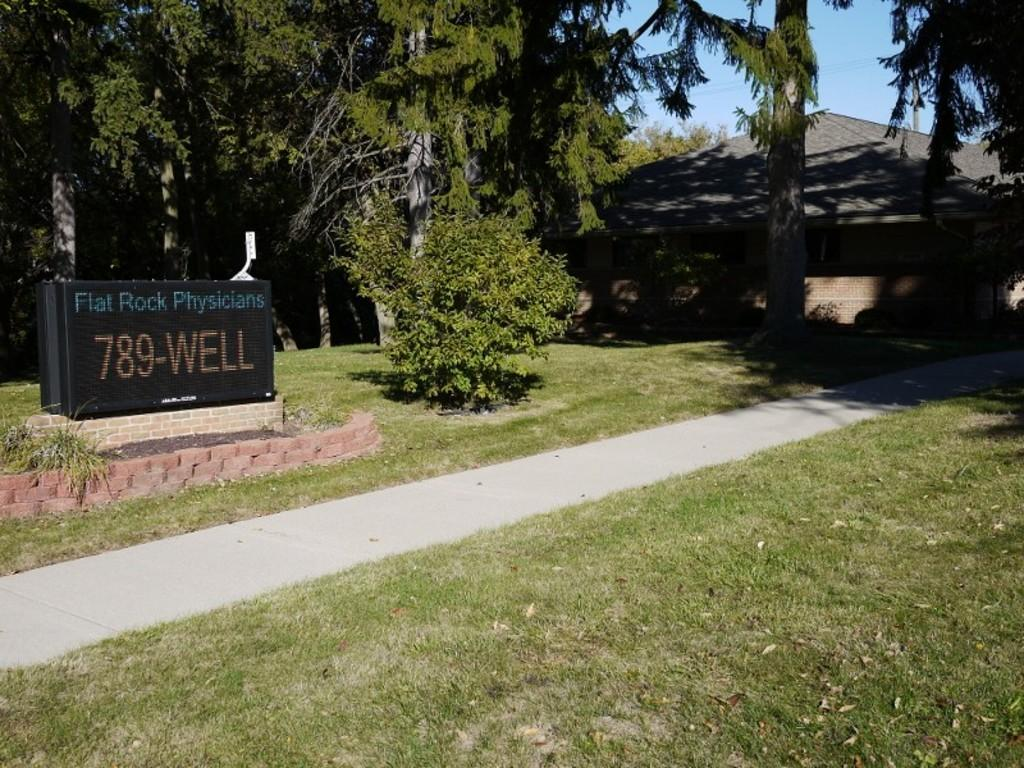What type of vegetation is present in the image? There are many grasses in the image. Where are the trees located in the image? The trees are on the left side of the image. What object is also located on the left side of the image? There is a board on the left side of the image. What structure can be seen in the background of the image? There is a house in the background of the image. How many icicles can be seen hanging from the trees in the image? There are no icicles present in the image, as it features grasses, trees, a board, and a house in a presumably warm environment. 